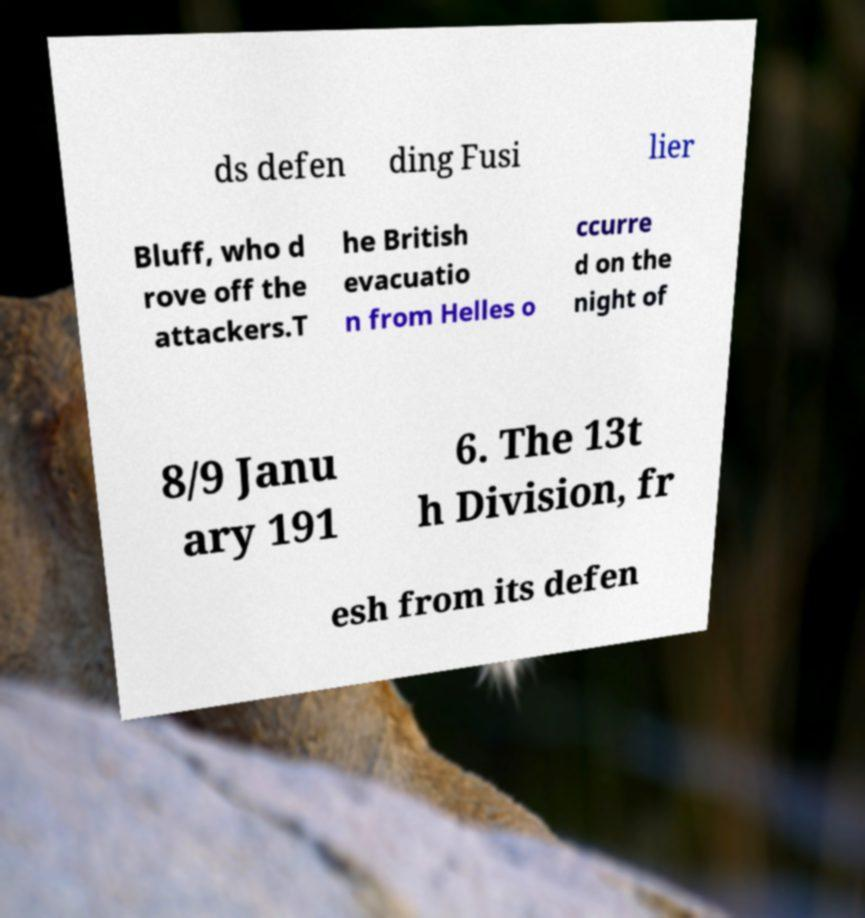Can you read and provide the text displayed in the image?This photo seems to have some interesting text. Can you extract and type it out for me? ds defen ding Fusi lier Bluff, who d rove off the attackers.T he British evacuatio n from Helles o ccurre d on the night of 8/9 Janu ary 191 6. The 13t h Division, fr esh from its defen 